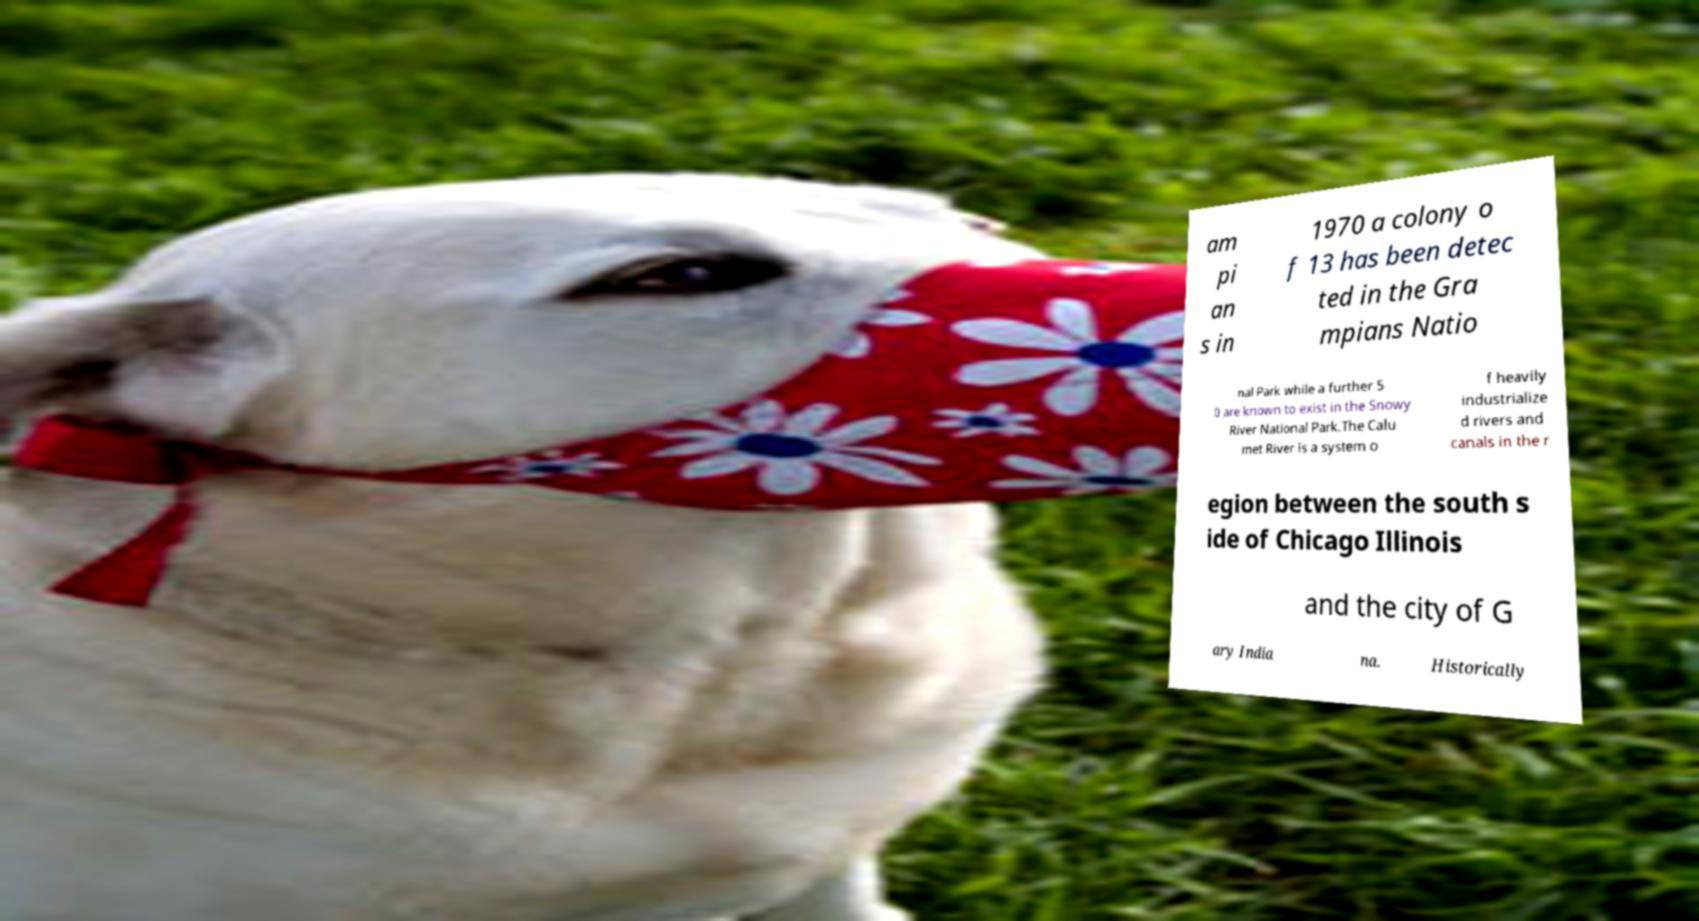Could you assist in decoding the text presented in this image and type it out clearly? am pi an s in 1970 a colony o f 13 has been detec ted in the Gra mpians Natio nal Park while a further 5 0 are known to exist in the Snowy River National Park.The Calu met River is a system o f heavily industrialize d rivers and canals in the r egion between the south s ide of Chicago Illinois and the city of G ary India na. Historically 